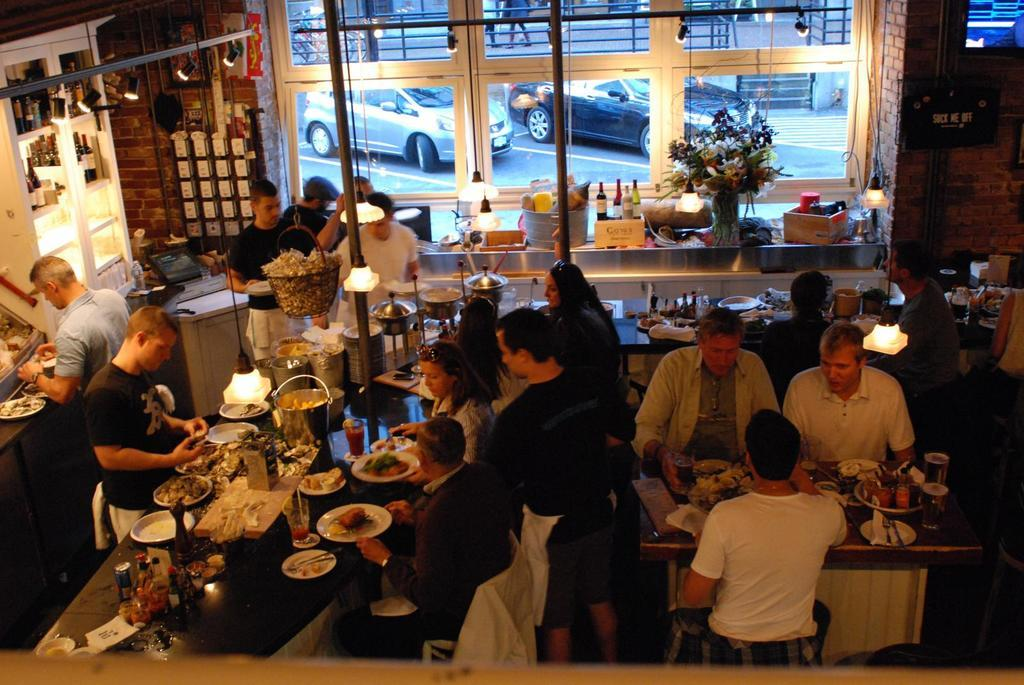What are the people in the image doing? The people in the image are sitting and having a meal. Are there any vehicles mentioned in the image? Yes, two cars are parked outside the building. Can you describe any interactions between the people in the image? Two persons are speaking with each other. What type of electronic device is present in the image? There is a television in the image. What type of fuel is being used by the cars in the image? There is no information about the type of fuel being used by the cars in the image. 